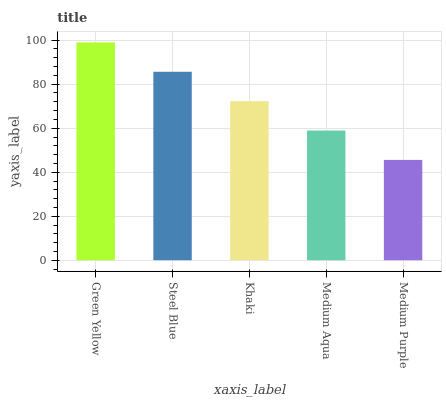Is Medium Purple the minimum?
Answer yes or no. Yes. Is Green Yellow the maximum?
Answer yes or no. Yes. Is Steel Blue the minimum?
Answer yes or no. No. Is Steel Blue the maximum?
Answer yes or no. No. Is Green Yellow greater than Steel Blue?
Answer yes or no. Yes. Is Steel Blue less than Green Yellow?
Answer yes or no. Yes. Is Steel Blue greater than Green Yellow?
Answer yes or no. No. Is Green Yellow less than Steel Blue?
Answer yes or no. No. Is Khaki the high median?
Answer yes or no. Yes. Is Khaki the low median?
Answer yes or no. Yes. Is Medium Aqua the high median?
Answer yes or no. No. Is Steel Blue the low median?
Answer yes or no. No. 